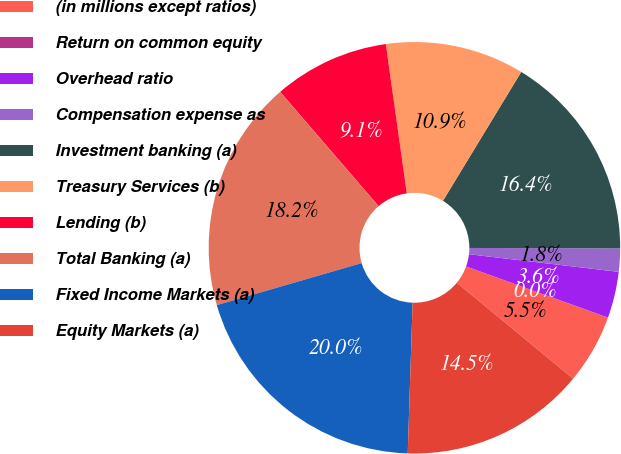<chart> <loc_0><loc_0><loc_500><loc_500><pie_chart><fcel>(in millions except ratios)<fcel>Return on common equity<fcel>Overhead ratio<fcel>Compensation expense as<fcel>Investment banking (a)<fcel>Treasury Services (b)<fcel>Lending (b)<fcel>Total Banking (a)<fcel>Fixed Income Markets (a)<fcel>Equity Markets (a)<nl><fcel>5.46%<fcel>0.01%<fcel>3.64%<fcel>1.82%<fcel>16.36%<fcel>10.91%<fcel>9.09%<fcel>18.18%<fcel>19.99%<fcel>14.54%<nl></chart> 